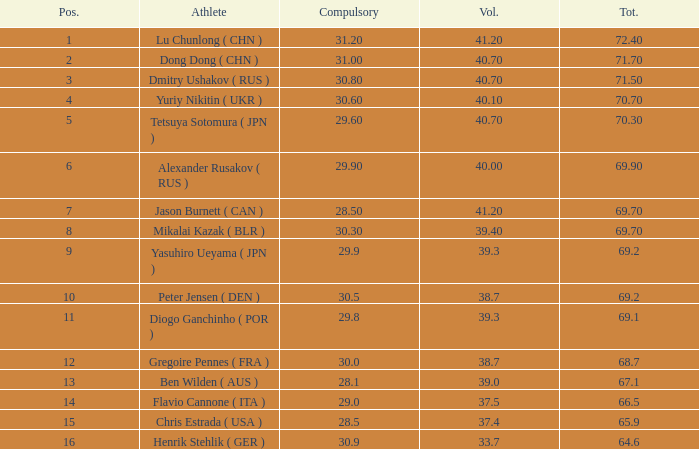What's the total of the position of 1? None. 